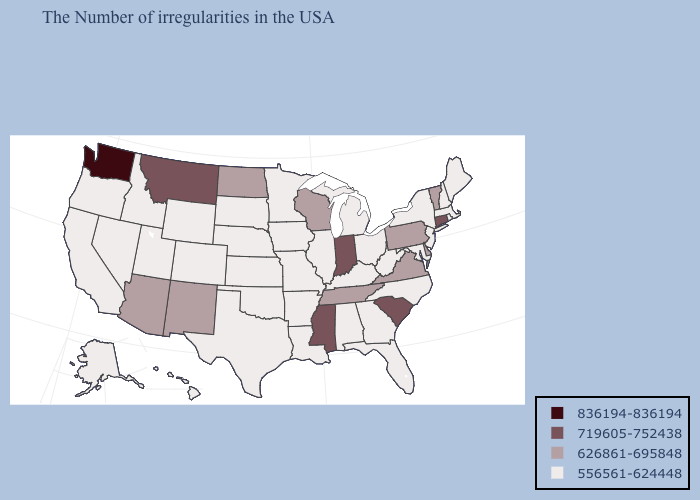Name the states that have a value in the range 556561-624448?
Quick response, please. Maine, Massachusetts, Rhode Island, New Hampshire, New York, New Jersey, Maryland, North Carolina, West Virginia, Ohio, Florida, Georgia, Michigan, Kentucky, Alabama, Illinois, Louisiana, Missouri, Arkansas, Minnesota, Iowa, Kansas, Nebraska, Oklahoma, Texas, South Dakota, Wyoming, Colorado, Utah, Idaho, Nevada, California, Oregon, Alaska, Hawaii. Among the states that border Oregon , which have the highest value?
Give a very brief answer. Washington. Name the states that have a value in the range 626861-695848?
Concise answer only. Vermont, Delaware, Pennsylvania, Virginia, Tennessee, Wisconsin, North Dakota, New Mexico, Arizona. Does New Mexico have a higher value than Virginia?
Quick response, please. No. What is the highest value in the West ?
Give a very brief answer. 836194-836194. What is the lowest value in the MidWest?
Give a very brief answer. 556561-624448. What is the highest value in the USA?
Be succinct. 836194-836194. What is the value of Georgia?
Give a very brief answer. 556561-624448. What is the value of Alabama?
Quick response, please. 556561-624448. Among the states that border Pennsylvania , which have the highest value?
Quick response, please. Delaware. What is the highest value in states that border Michigan?
Concise answer only. 719605-752438. What is the value of Missouri?
Quick response, please. 556561-624448. What is the value of New Jersey?
Write a very short answer. 556561-624448. Name the states that have a value in the range 836194-836194?
Be succinct. Washington. What is the value of Massachusetts?
Quick response, please. 556561-624448. 